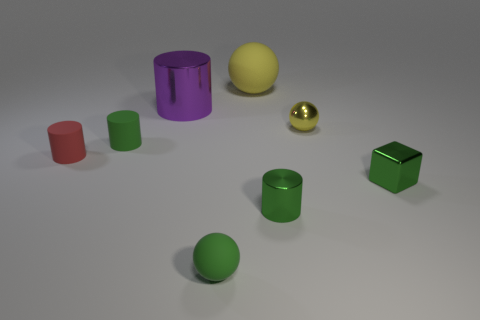The yellow thing that is the same material as the tiny green ball is what shape?
Provide a succinct answer. Sphere. Is there anything else that is the same color as the metal cube?
Offer a terse response. Yes. How many large cylinders are there?
Offer a terse response. 1. There is a yellow object behind the cylinder that is behind the yellow metallic sphere; what is it made of?
Offer a very short reply. Rubber. The metal cylinder that is on the left side of the tiny matte object in front of the tiny cylinder left of the tiny green matte cylinder is what color?
Your answer should be compact. Purple. Is the tiny shiny cylinder the same color as the metallic cube?
Your answer should be very brief. Yes. What number of shiny blocks have the same size as the red cylinder?
Your response must be concise. 1. Is the number of purple shiny things that are to the right of the purple metal cylinder greater than the number of tiny green metallic objects behind the yellow matte ball?
Give a very brief answer. No. There is a sphere that is in front of the green thing right of the tiny yellow object; what color is it?
Give a very brief answer. Green. Is the big yellow object made of the same material as the big purple thing?
Keep it short and to the point. No. 